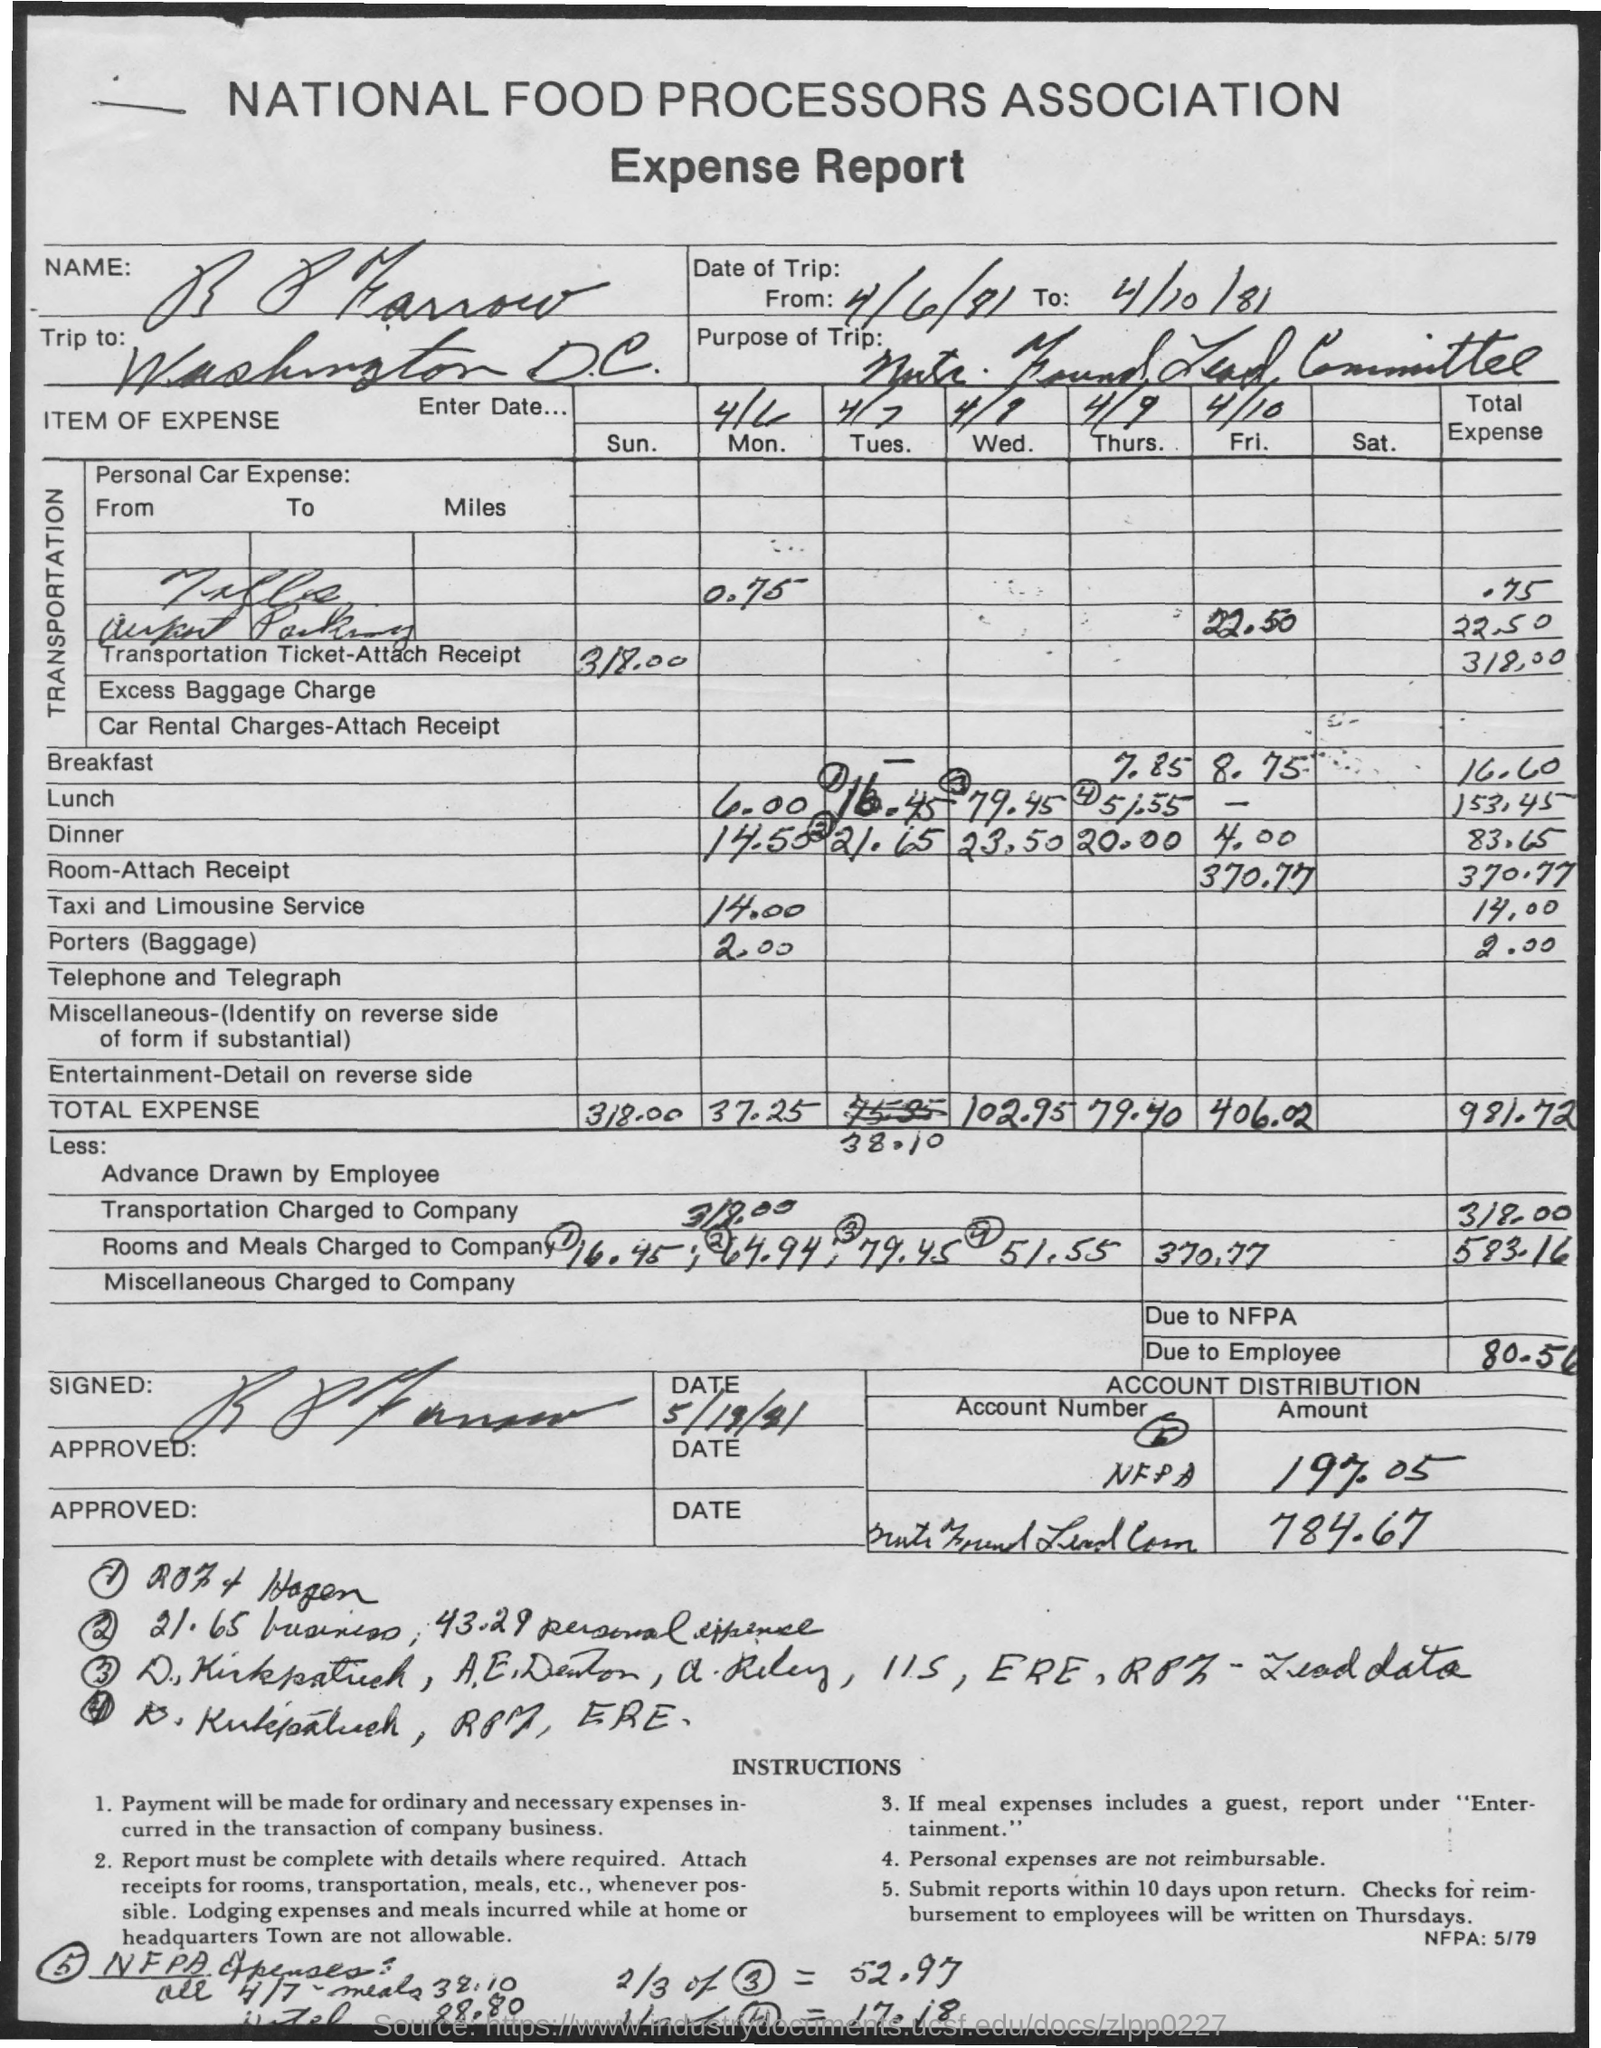Can you explain what the purpose of the trip was? The purpose of the trip documented in the image appears to be related to a meeting with the 'Exec. Board/Staff Committee' in Washington D.C., as noted in the 'Purpose of Trip' section of the expense report. 